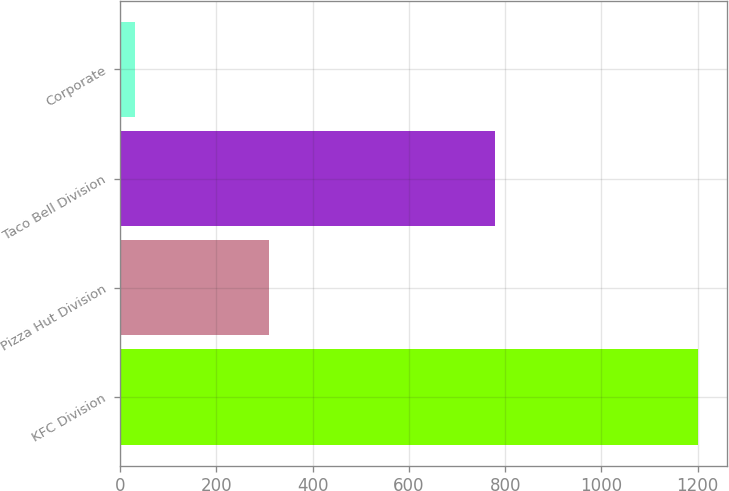Convert chart to OTSL. <chart><loc_0><loc_0><loc_500><loc_500><bar_chart><fcel>KFC Division<fcel>Pizza Hut Division<fcel>Taco Bell Division<fcel>Corporate<nl><fcel>1200<fcel>310<fcel>778<fcel>31<nl></chart> 